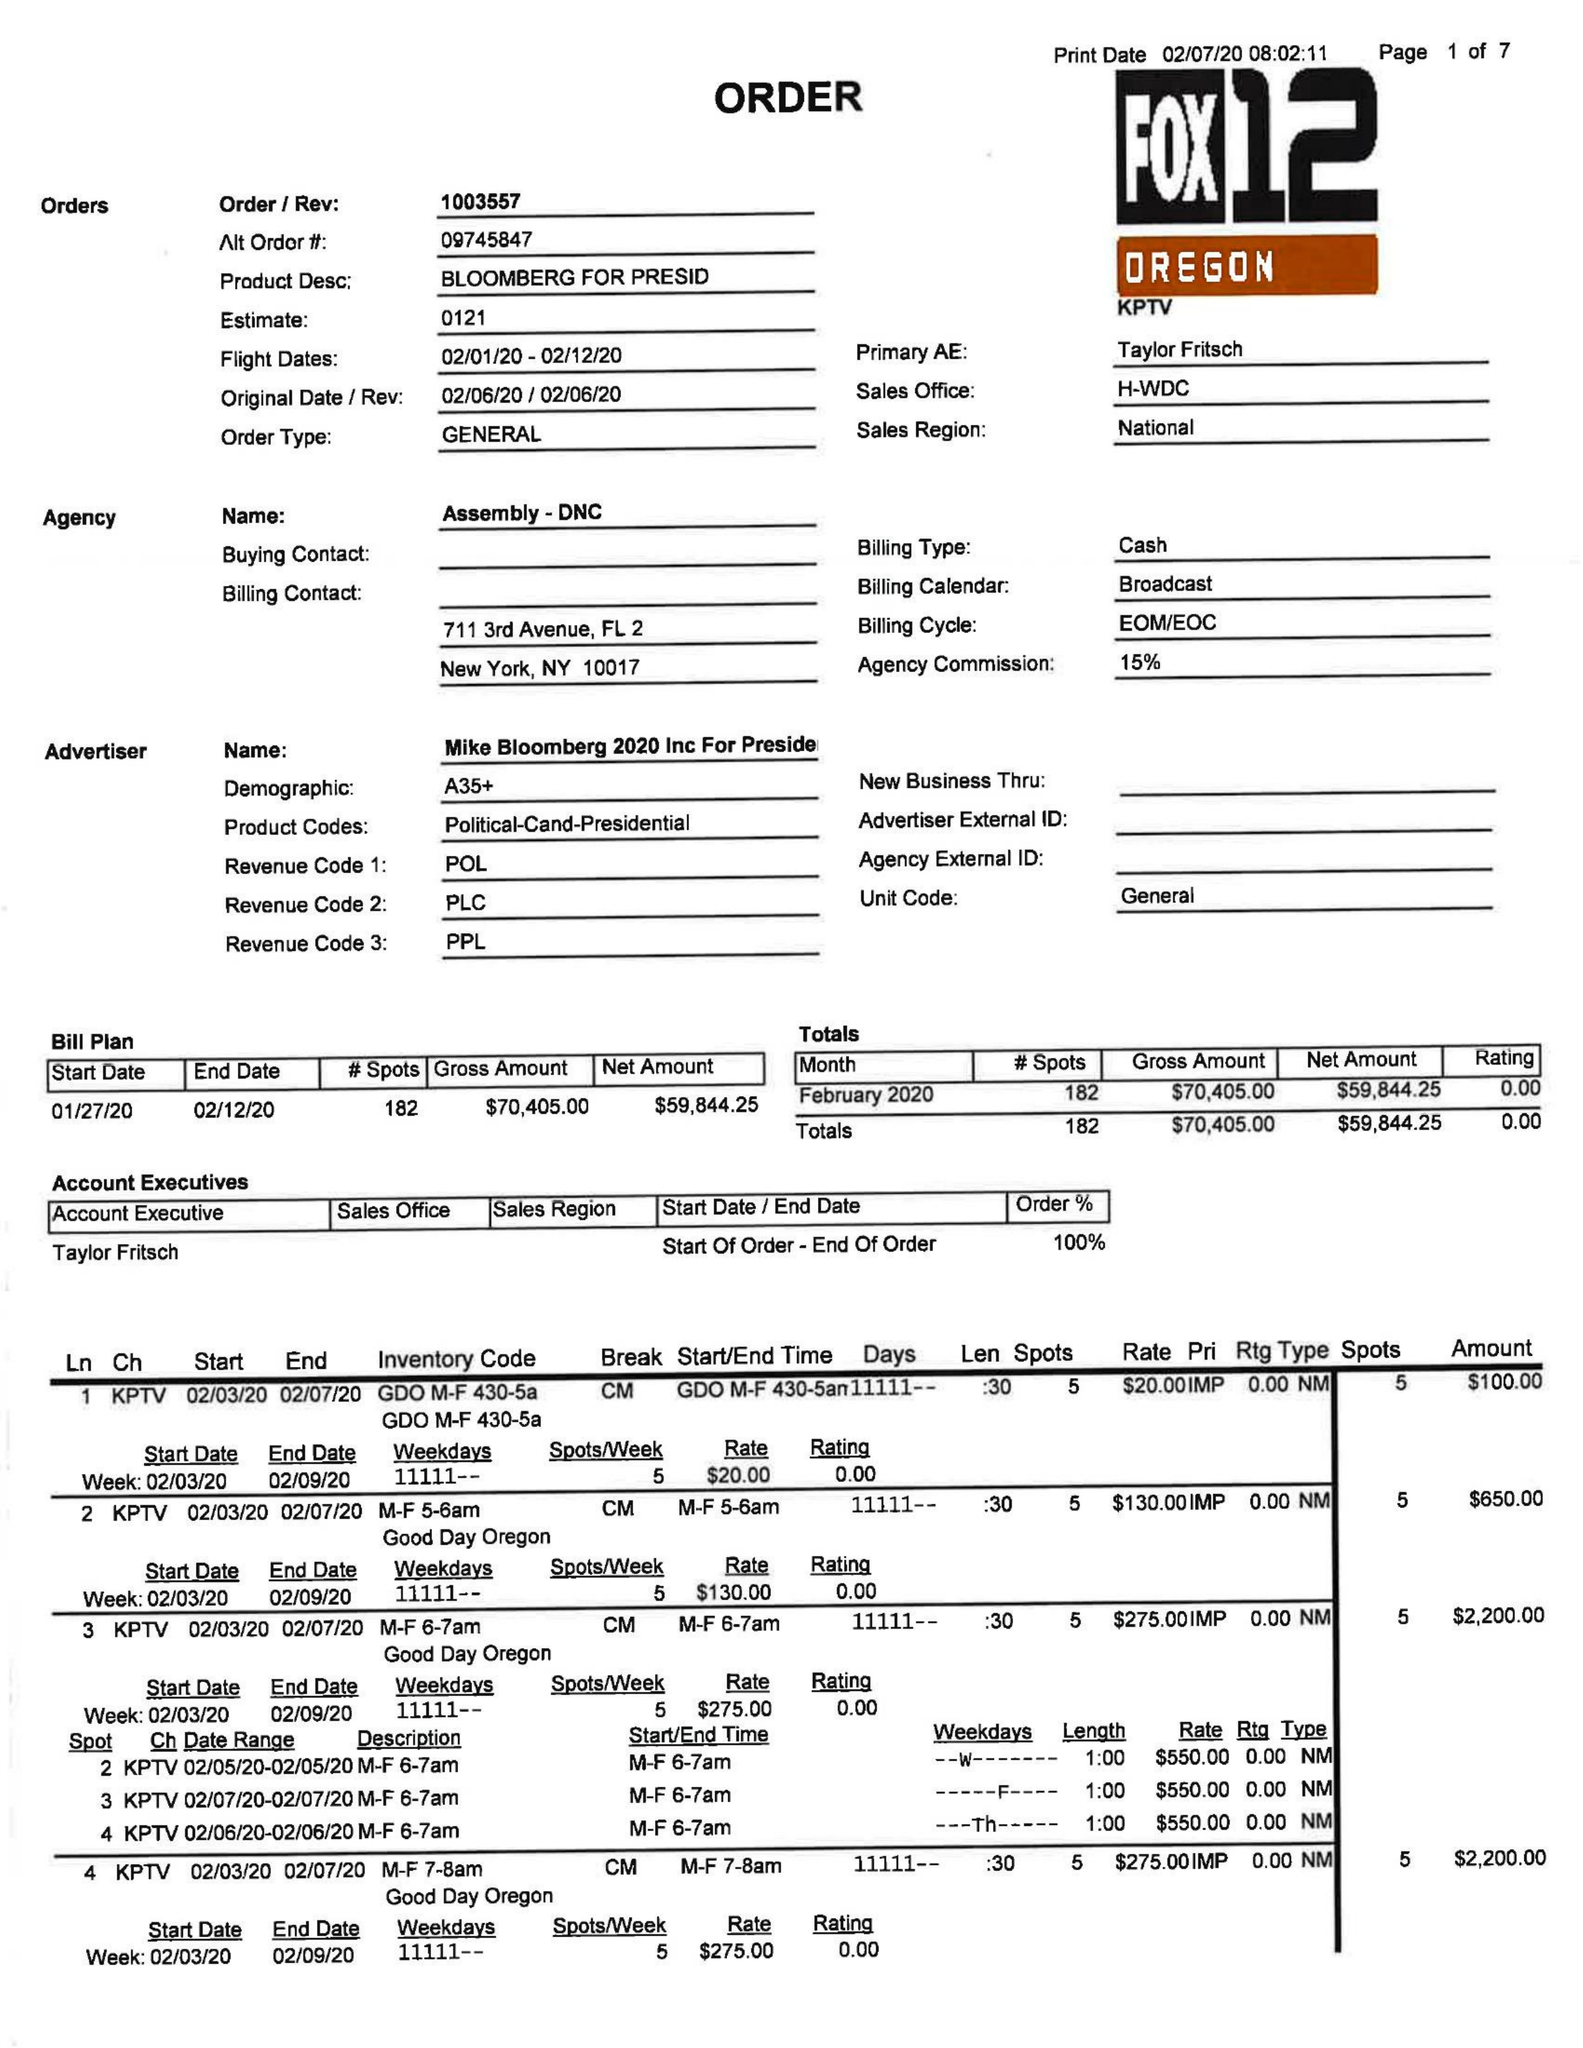What is the value for the contract_num?
Answer the question using a single word or phrase. 1003557 